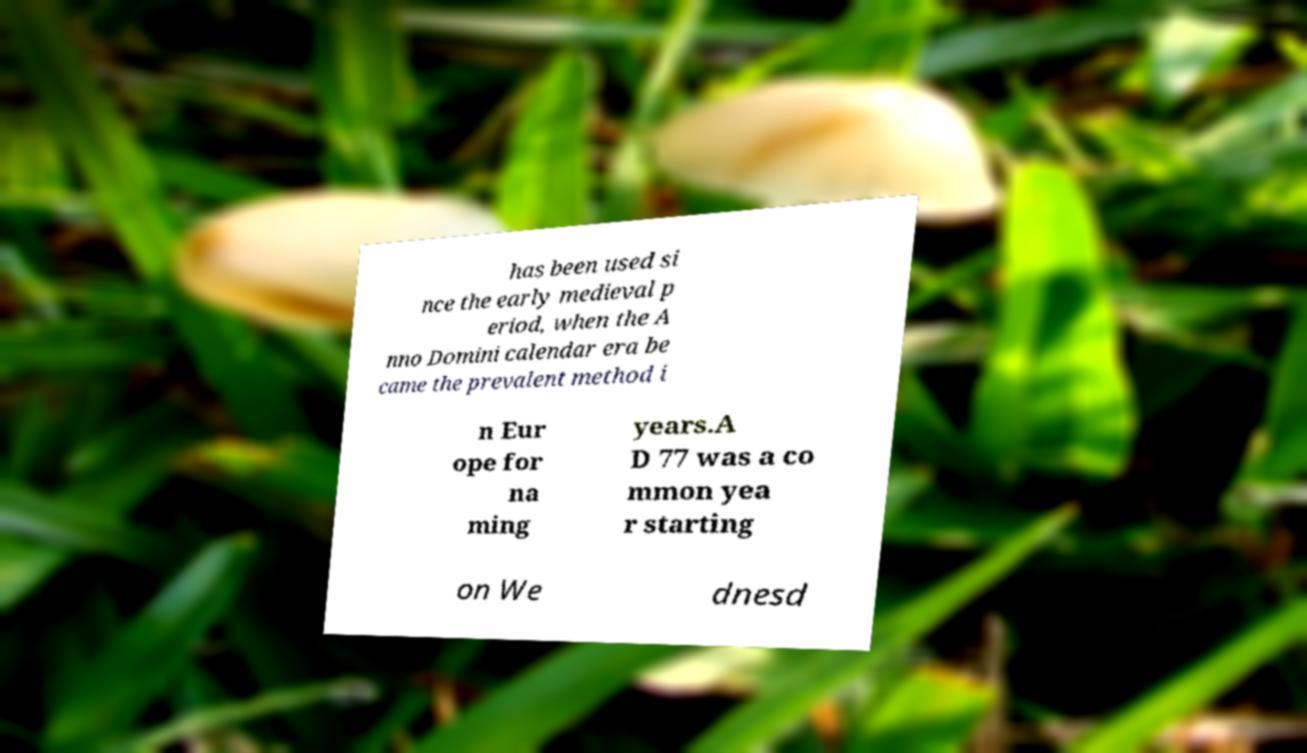I need the written content from this picture converted into text. Can you do that? has been used si nce the early medieval p eriod, when the A nno Domini calendar era be came the prevalent method i n Eur ope for na ming years.A D 77 was a co mmon yea r starting on We dnesd 